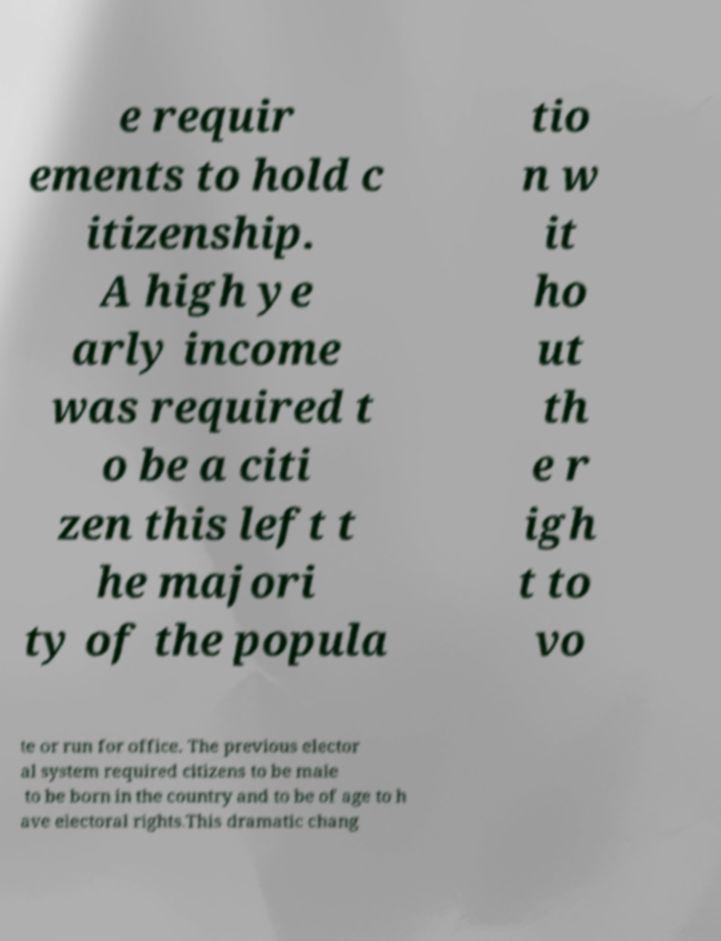Could you extract and type out the text from this image? e requir ements to hold c itizenship. A high ye arly income was required t o be a citi zen this left t he majori ty of the popula tio n w it ho ut th e r igh t to vo te or run for office. The previous elector al system required citizens to be male to be born in the country and to be of age to h ave electoral rights.This dramatic chang 